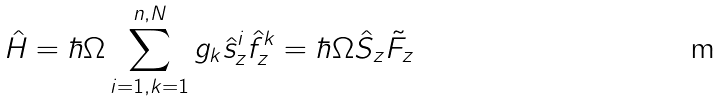Convert formula to latex. <formula><loc_0><loc_0><loc_500><loc_500>\hat { H } = \hbar { \Omega } \sum _ { i = 1 , k = 1 } ^ { n , N } g _ { k } \hat { s } ^ { i } _ { z } \hat { f } ^ { k } _ { z } = \hbar { \Omega } \hat { S } _ { z } \tilde { F } _ { z }</formula> 